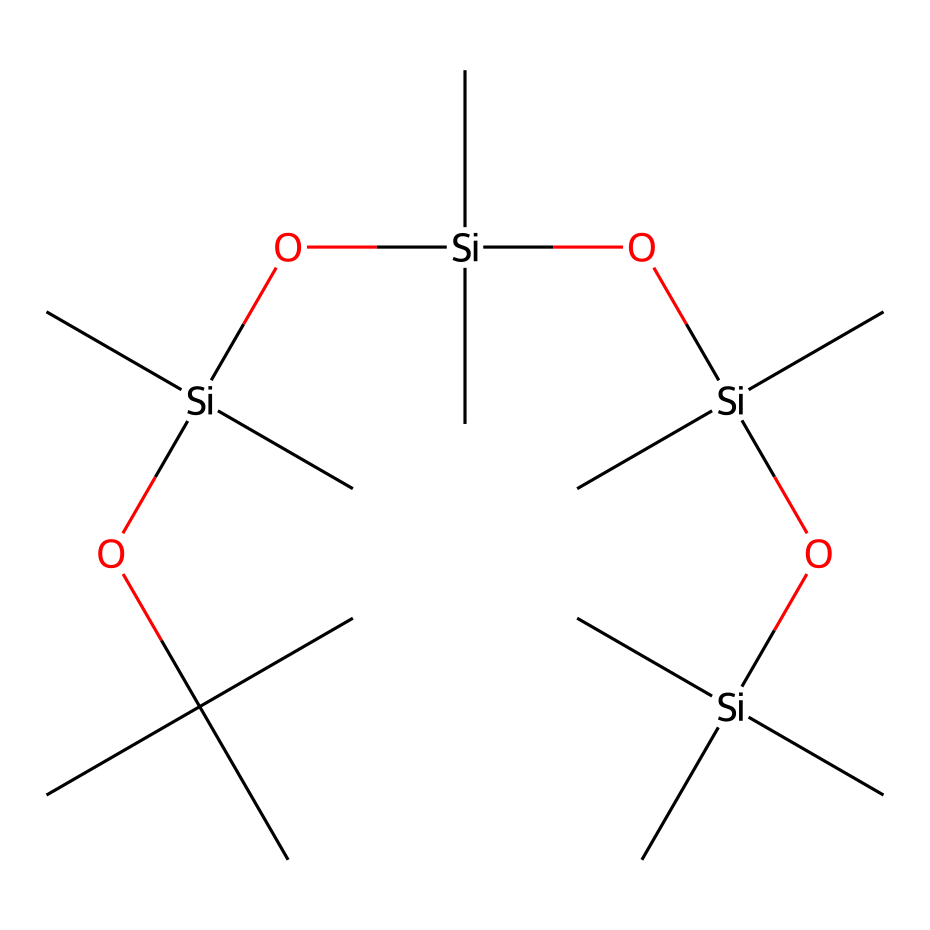What is the main element in this chemical structure? The chemical structure contains silicon atoms, indicated by the symbol 'Si'. Throughout the structure, silicon is the central atom bonded to various groups.
Answer: silicon How many silicon atoms are present in this compound? By examining the given SMILES representation, we can count the number of 'Si' symbols. There are four 'Si', indicating there are four silicon atoms in total.
Answer: four What functional groups can be identified in the chemical structure? The chemical structure contains siloxy (Si-O) and alkyl groups (C). The branches from the silicon atoms show the presence of C atoms connected to it, indicating the presence of both functional types.
Answer: siloxy and alkyl How many total carbon atoms are in this compound? In the SMILES representation, each 'C' corresponds to a carbon atom. Counting all carbon atoms in the structure shows there are 18 carbon atoms.
Answer: eighteen What type of compounds does this chemical belong to? This chemical falls under the category of organosilicon compounds, which are characterized by the presence of silicon atoms in the molecular structure combined with organic groups.
Answer: organosilicon What is the significance of the 'O' atoms in the structure? The 'O' atoms represent oxygen atoms, which are part of the siloxy groups, linking silicon atoms and playing a crucial role in imparting the material properties of the silicone-based makeup primer.
Answer: linking agents How does the branching in this structure contribute to its properties? The branching of alkyl groups off the silicon backbone increases the hydrophobic nature of the silicone compound, enhancing its smooth application and water resistance, which is beneficial for makeup primers.
Answer: hydrophobic qualities 